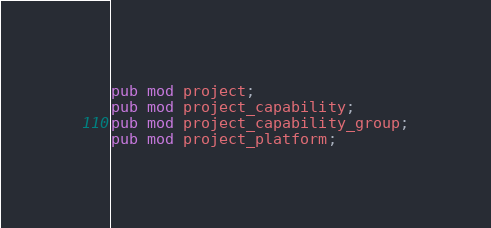<code> <loc_0><loc_0><loc_500><loc_500><_Rust_>pub mod project;
pub mod project_capability;
pub mod project_capability_group;
pub mod project_platform;
</code> 